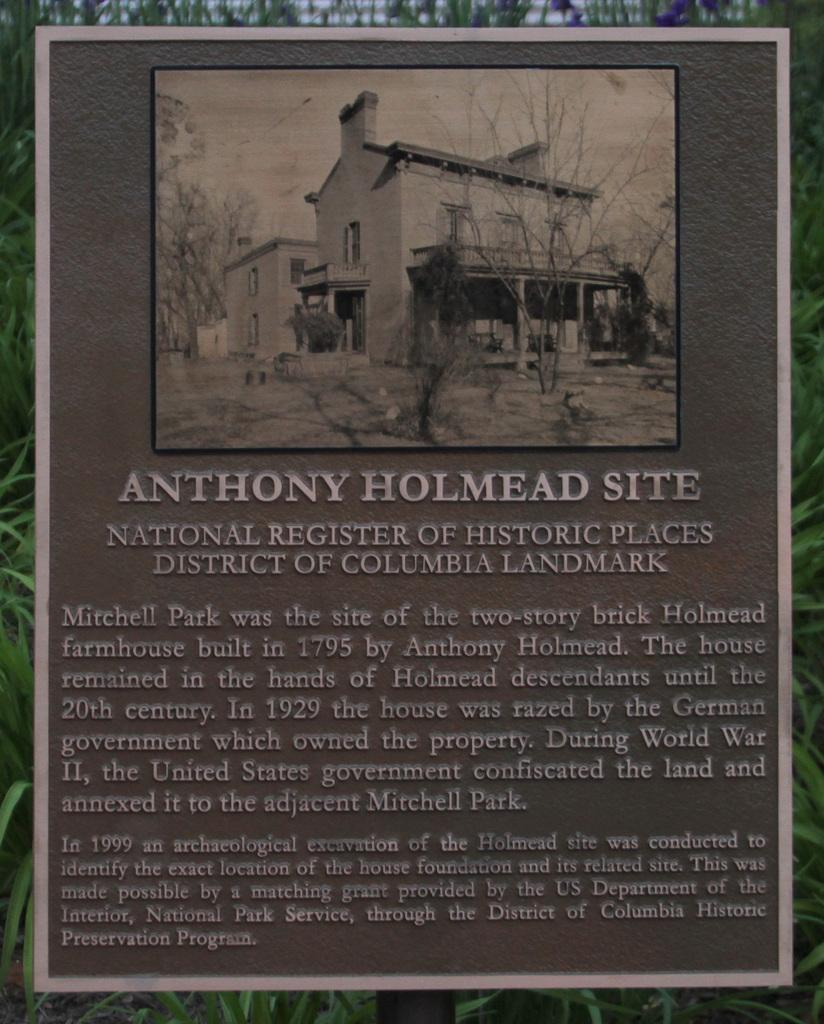What is the main subject of the image? The main subject of the image is a picture on a board. What else can be seen on the board besides the picture? There are texts on the board. What type of vegetation is visible in the background of the image? There are plants in the background of some kind in the background of the image. What is the price of the plants in the image? There is no information about the price of the plants in the image, as the focus is on the picture on the board and the texts on the board. 